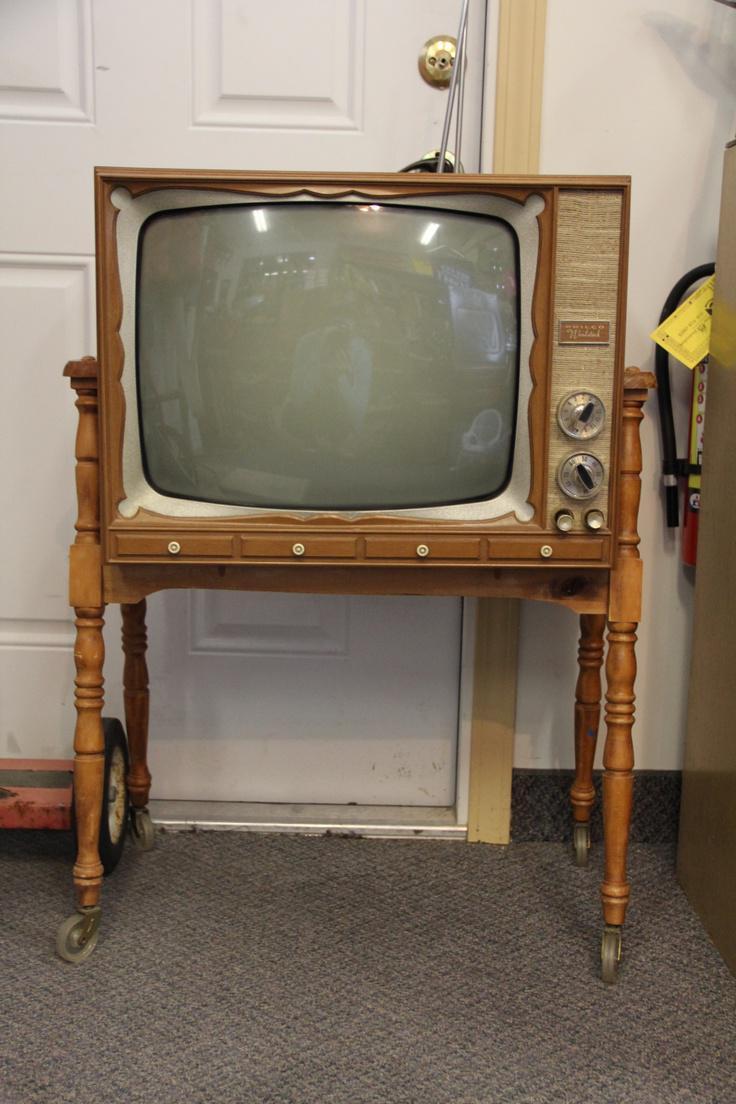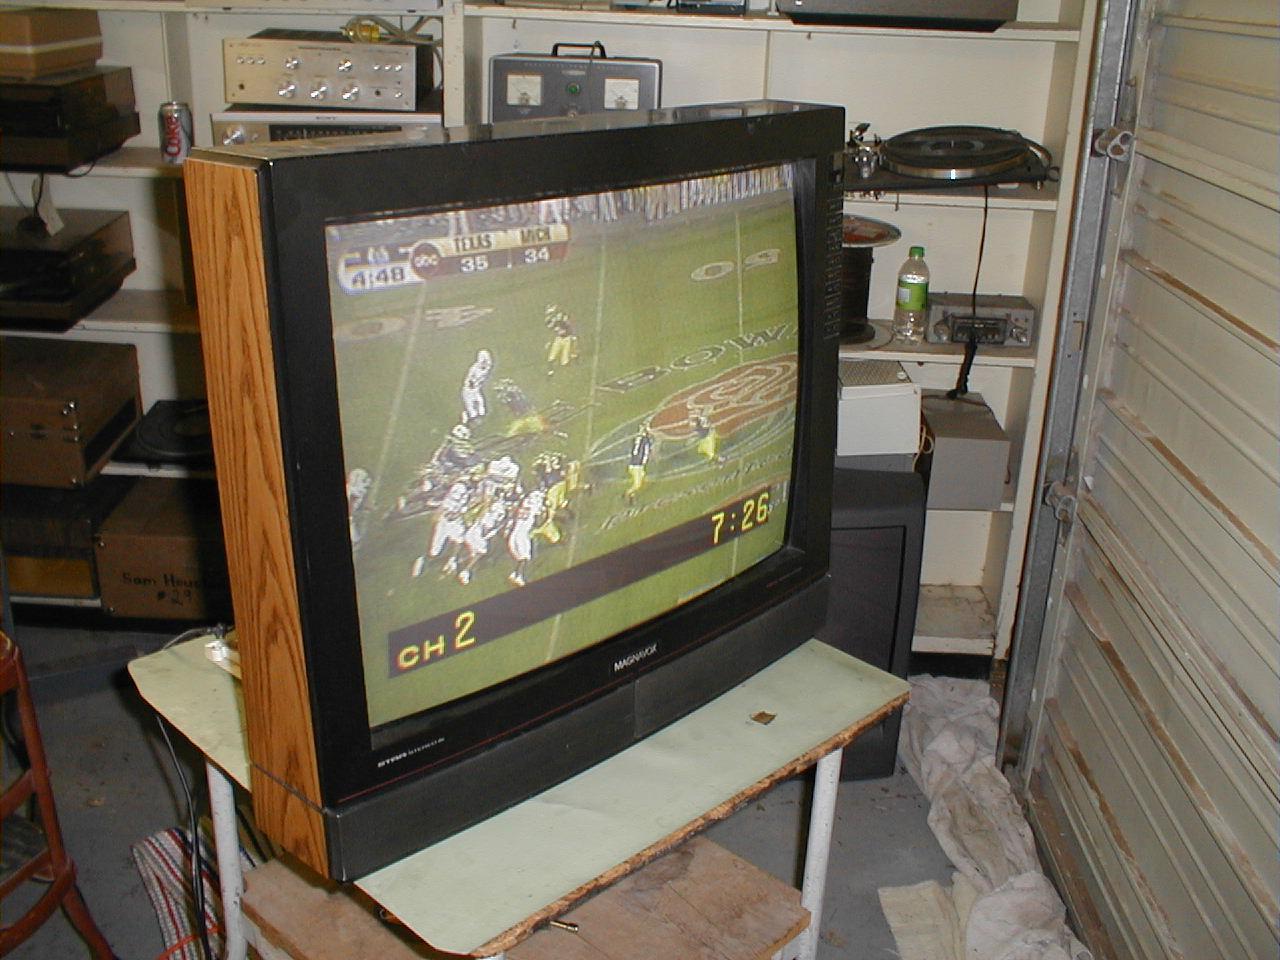The first image is the image on the left, the second image is the image on the right. Analyze the images presented: Is the assertion "There are two tvs, and one of them has had its screen removed." valid? Answer yes or no. No. The first image is the image on the left, the second image is the image on the right. Given the left and right images, does the statement "At least one animal is inside a hollowed out antique television set." hold true? Answer yes or no. No. 